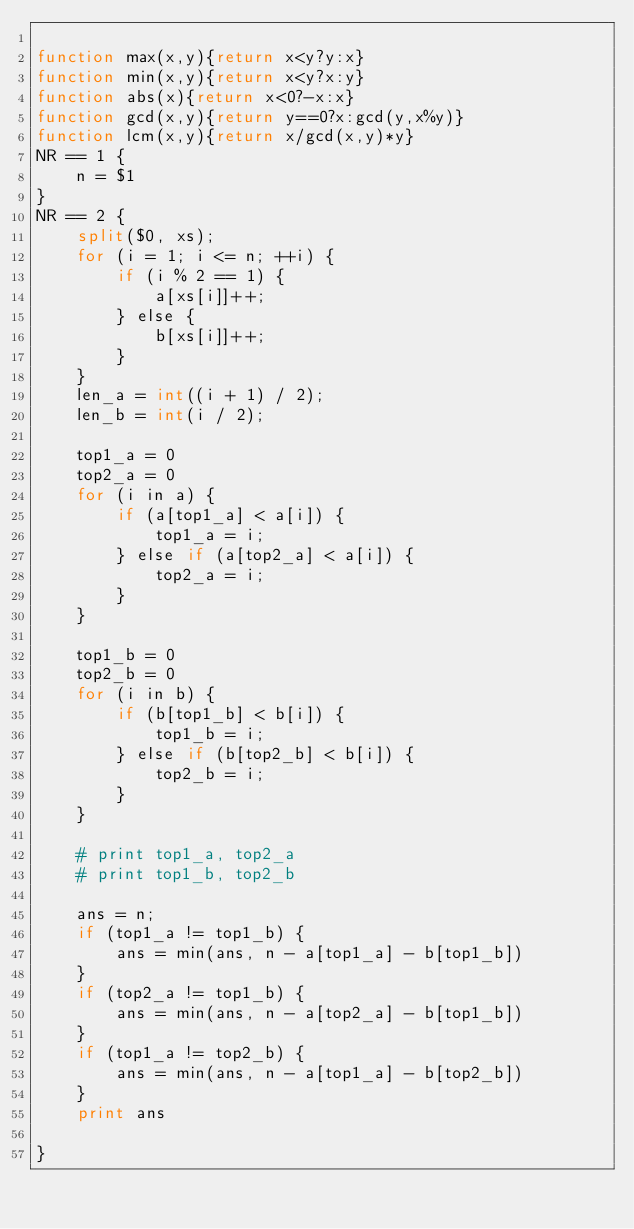<code> <loc_0><loc_0><loc_500><loc_500><_Awk_>
function max(x,y){return x<y?y:x}
function min(x,y){return x<y?x:y}
function abs(x){return x<0?-x:x}
function gcd(x,y){return y==0?x:gcd(y,x%y)}
function lcm(x,y){return x/gcd(x,y)*y}
NR == 1 {
    n = $1
}
NR == 2 {
    split($0, xs);
    for (i = 1; i <= n; ++i) {
        if (i % 2 == 1) {
            a[xs[i]]++;
        } else {
            b[xs[i]]++;
        }
    }
    len_a = int((i + 1) / 2);
    len_b = int(i / 2);

    top1_a = 0
    top2_a = 0
    for (i in a) {
        if (a[top1_a] < a[i]) {
            top1_a = i;
        } else if (a[top2_a] < a[i]) {
            top2_a = i;
        }
    }

    top1_b = 0
    top2_b = 0
    for (i in b) {
        if (b[top1_b] < b[i]) {
            top1_b = i;
        } else if (b[top2_b] < b[i]) {
            top2_b = i;
        }
    }

    # print top1_a, top2_a
    # print top1_b, top2_b

    ans = n;
    if (top1_a != top1_b) {
        ans = min(ans, n - a[top1_a] - b[top1_b])
    }
    if (top2_a != top1_b) {
        ans = min(ans, n - a[top2_a] - b[top1_b])
    }
    if (top1_a != top2_b) {
        ans = min(ans, n - a[top1_a] - b[top2_b])
    }
    print ans

}

</code> 